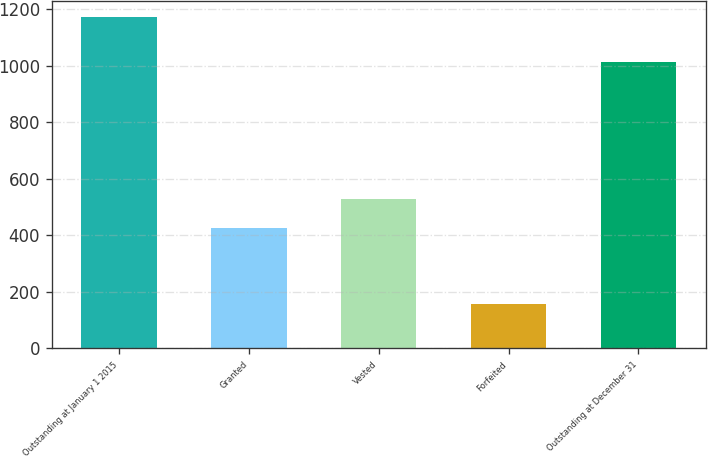<chart> <loc_0><loc_0><loc_500><loc_500><bar_chart><fcel>Outstanding at January 1 2015<fcel>Granted<fcel>Vested<fcel>Forfeited<fcel>Outstanding at December 31<nl><fcel>1171<fcel>426<fcel>527.3<fcel>158<fcel>1013<nl></chart> 